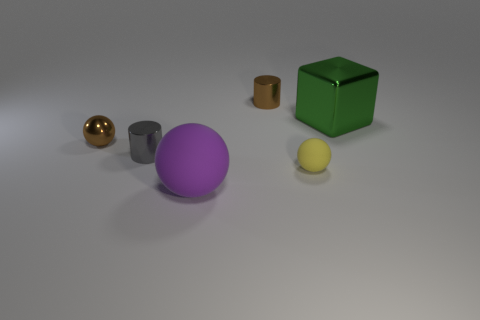Do the tiny thing that is in front of the gray cylinder and the gray object have the same shape?
Your response must be concise. No. How many objects are either metallic things or small things in front of the big metallic cube?
Your response must be concise. 5. Is the number of tiny yellow rubber blocks less than the number of green things?
Offer a terse response. Yes. Are there more big red shiny cubes than brown shiny things?
Your response must be concise. No. How many other objects are there of the same material as the yellow sphere?
Keep it short and to the point. 1. There is a tiny thing that is right of the brown object behind the brown metal sphere; how many cylinders are behind it?
Your answer should be compact. 2. How many metal objects are either big red balls or yellow objects?
Offer a very short reply. 0. There is a matte ball on the right side of the small metal cylinder behind the tiny gray shiny cylinder; what size is it?
Your answer should be compact. Small. There is a tiny metallic cylinder that is in front of the brown shiny cylinder; does it have the same color as the shiny cylinder to the right of the big purple rubber thing?
Offer a very short reply. No. What color is the ball that is both right of the gray shiny thing and behind the purple matte sphere?
Keep it short and to the point. Yellow. 